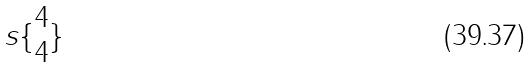Convert formula to latex. <formula><loc_0><loc_0><loc_500><loc_500>s \{ \begin{matrix} 4 \\ 4 \end{matrix} \}</formula> 